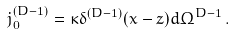<formula> <loc_0><loc_0><loc_500><loc_500>j ^ { ( D - 1 ) } _ { 0 } = \kappa \delta ^ { ( D - 1 ) } ( x - z ) d \Omega ^ { D - 1 } \, .</formula> 